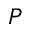Convert formula to latex. <formula><loc_0><loc_0><loc_500><loc_500>P</formula> 